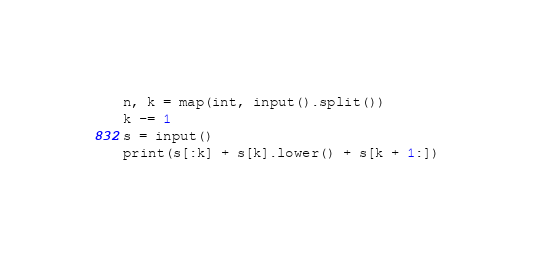<code> <loc_0><loc_0><loc_500><loc_500><_Python_>n, k = map(int, input().split())
k -= 1
s = input()
print(s[:k] + s[k].lower() + s[k + 1:])</code> 